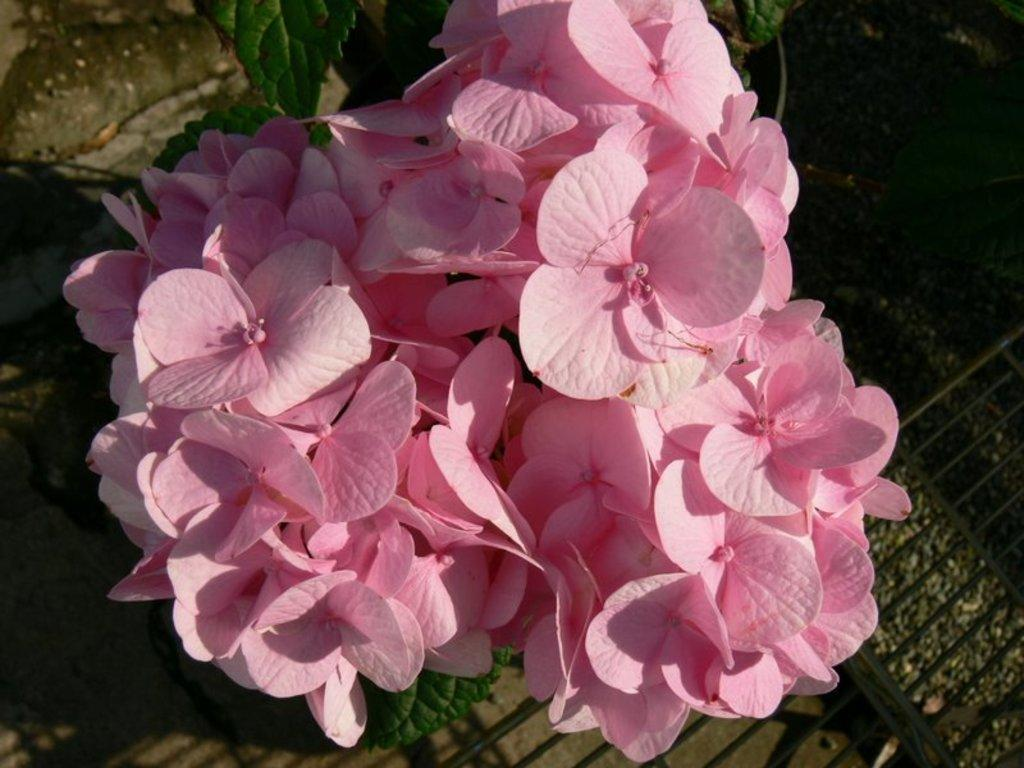What type of plant is featured in the image? There is a plant with pink flowers in the image. What can be seen behind the plant? There is a barrier behind the plant. Can you see a deer grazing near the plant in the image? There is no deer present in the image. What phase is the moon in during the time the image was taken? The image does not provide any information about the moon or its phase. 